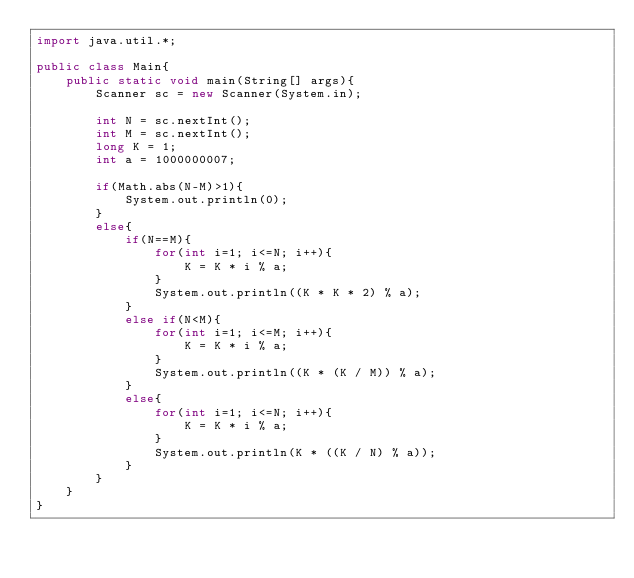<code> <loc_0><loc_0><loc_500><loc_500><_Java_>import java.util.*;
 
public class Main{
    public static void main(String[] args){
        Scanner sc = new Scanner(System.in);
 
        int N = sc.nextInt();
        int M = sc.nextInt();
        long K = 1;
        int a = 1000000007;
        
        if(Math.abs(N-M)>1){
            System.out.println(0);
        }
        else{
            if(N==M){
                for(int i=1; i<=N; i++){
                    K = K * i % a;
                }
                System.out.println((K * K * 2) % a);
            }
            else if(N<M){
                for(int i=1; i<=M; i++){
                    K = K * i % a;
                }
                System.out.println((K * (K / M)) % a);
            }
            else{
                for(int i=1; i<=N; i++){
                    K = K * i % a;
                }
                System.out.println(K * ((K / N) % a));
            }
        }
    }
}</code> 